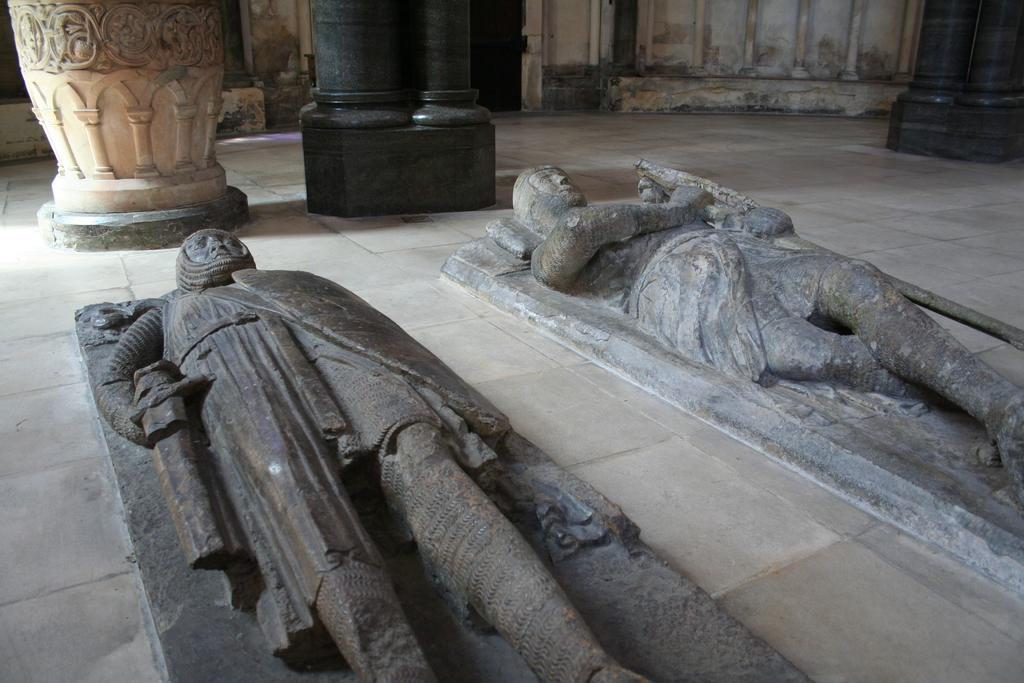In one or two sentences, can you explain what this image depicts? This picture consists of sculptures and pillars. 